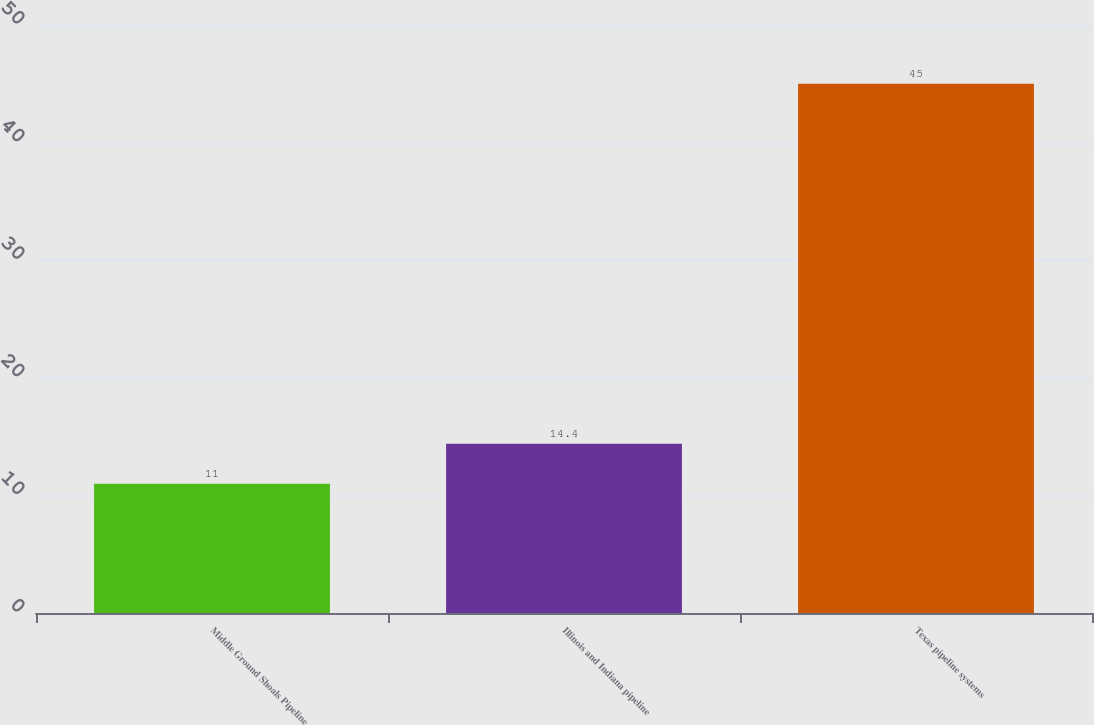Convert chart to OTSL. <chart><loc_0><loc_0><loc_500><loc_500><bar_chart><fcel>Middle Ground Shoals Pipeline<fcel>Illinois and Indiana pipeline<fcel>Texas pipeline systems<nl><fcel>11<fcel>14.4<fcel>45<nl></chart> 